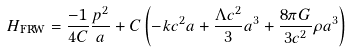Convert formula to latex. <formula><loc_0><loc_0><loc_500><loc_500>H _ { \text {FRW} } = \frac { - 1 } { 4 C } \frac { p ^ { 2 } } { a } + C \left ( - k c ^ { 2 } a + \frac { \Lambda c ^ { 2 } } { 3 } a ^ { 3 } + \frac { 8 \pi G } { 3 c ^ { 2 } } \rho a ^ { 3 } \right )</formula> 